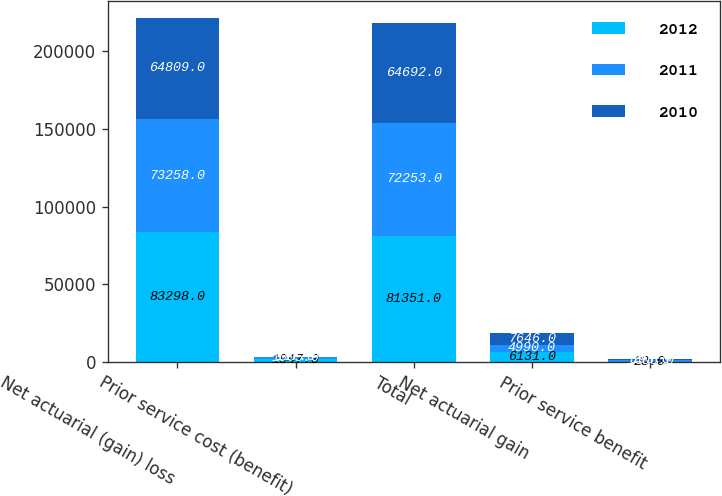<chart> <loc_0><loc_0><loc_500><loc_500><stacked_bar_chart><ecel><fcel>Net actuarial (gain) loss<fcel>Prior service cost (benefit)<fcel>Total<fcel>Net actuarial gain<fcel>Prior service benefit<nl><fcel>2012<fcel>83298<fcel>1947<fcel>81351<fcel>6131<fcel>23<nl><fcel>2011<fcel>73258<fcel>1005<fcel>72253<fcel>4990<fcel>1406<nl><fcel>2010<fcel>64809<fcel>117<fcel>64692<fcel>7646<fcel>193<nl></chart> 